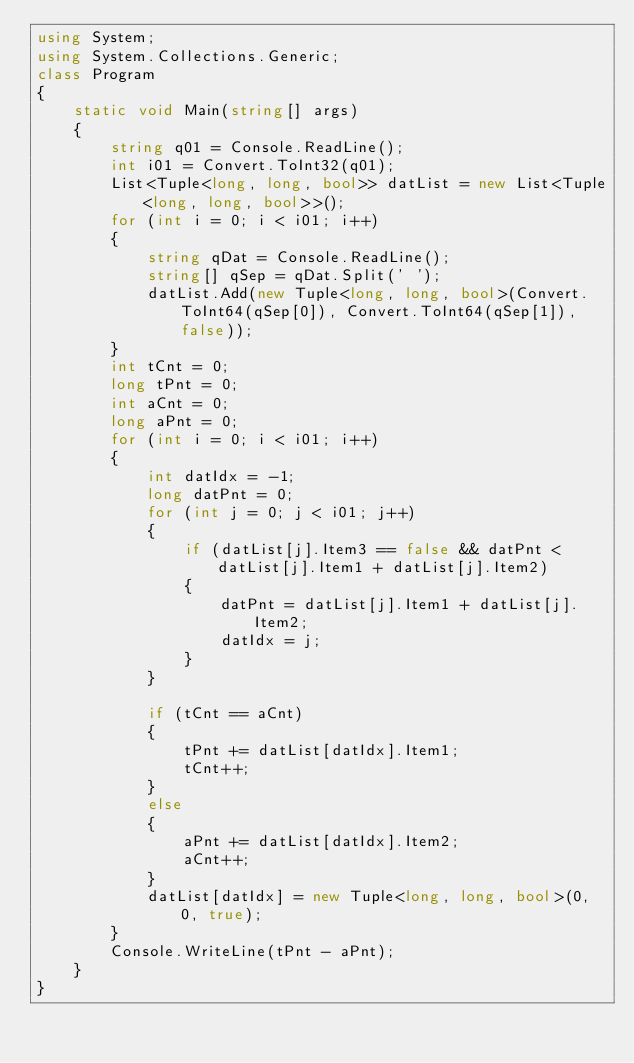<code> <loc_0><loc_0><loc_500><loc_500><_C#_>using System;
using System.Collections.Generic;
class Program
{
    static void Main(string[] args)
    {
        string q01 = Console.ReadLine();
        int i01 = Convert.ToInt32(q01);
        List<Tuple<long, long, bool>> datList = new List<Tuple<long, long, bool>>();  
        for (int i = 0; i < i01; i++)
        {
            string qDat = Console.ReadLine();
            string[] qSep = qDat.Split(' ');
            datList.Add(new Tuple<long, long, bool>(Convert.ToInt64(qSep[0]), Convert.ToInt64(qSep[1]), false));
        }
        int tCnt = 0;
        long tPnt = 0;
        int aCnt = 0;
        long aPnt = 0;
        for (int i = 0; i < i01; i++)
        {
            int datIdx = -1;
            long datPnt = 0;
            for (int j = 0; j < i01; j++)
            {
                if (datList[j].Item3 == false && datPnt < datList[j].Item1 + datList[j].Item2)
                {
                    datPnt = datList[j].Item1 + datList[j].Item2;
                    datIdx = j;
                }
            }

            if (tCnt == aCnt)
            {
                tPnt += datList[datIdx].Item1;
                tCnt++;
            }
            else
            {
                aPnt += datList[datIdx].Item2;
                aCnt++;
            }
            datList[datIdx] = new Tuple<long, long, bool>(0, 0, true);
        }
        Console.WriteLine(tPnt - aPnt);
    }
}</code> 